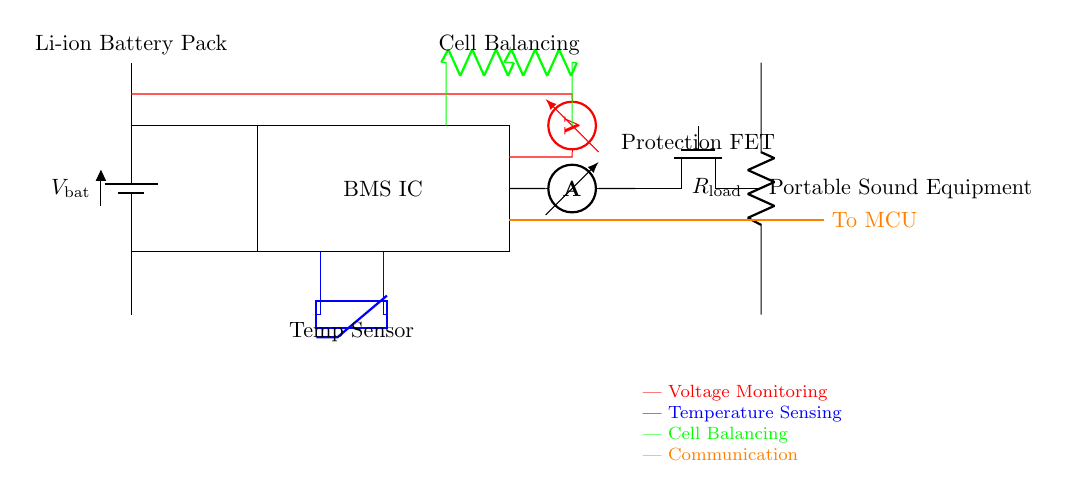what type of battery is used in this circuit? The circuit indicates a Li-ion Battery Pack, which is specifically labeled at the top of the battery component in the diagram.
Answer: Li-ion Battery Pack what does the BMS IC do in this circuit? The BMS IC, or Battery Management System Integrated Circuit, regulates the battery usage for safety and efficiency by monitoring various parameters within the circuit.
Answer: Regulates battery usage what component is used for current sensing? An ammeter is used for current sensing, which is depicted in the diagram and measures the flow of current through the circuit.
Answer: Ammeter how many functions does the BMS perform in this circuit? The BMS performs multiple functions including voltage monitoring, temperature sensing, cell balancing, and communication, as indicated by the corresponding components and paths connected to it.
Answer: Four functions what happens to the current flow when the protection FET is activated? When the protection FET is activated, it typically interrupts the current flow to protect the circuit from overcurrent conditions, ensuring safe operation of the portable sound equipment.
Answer: Interrupts current flow what type of sensor is included for temperature monitoring? The temperature sensor shown is a thermistor, labeled clearly in the diagram, which measures temperature changes to help maintain battery health.
Answer: Thermistor how is communication between the BMS and MCU established? Communication is established through an orange line connecting the BMS IC to the MCU, as depicted in the diagram, facilitating data transfer for monitoring and control purposes.
Answer: Orange line 